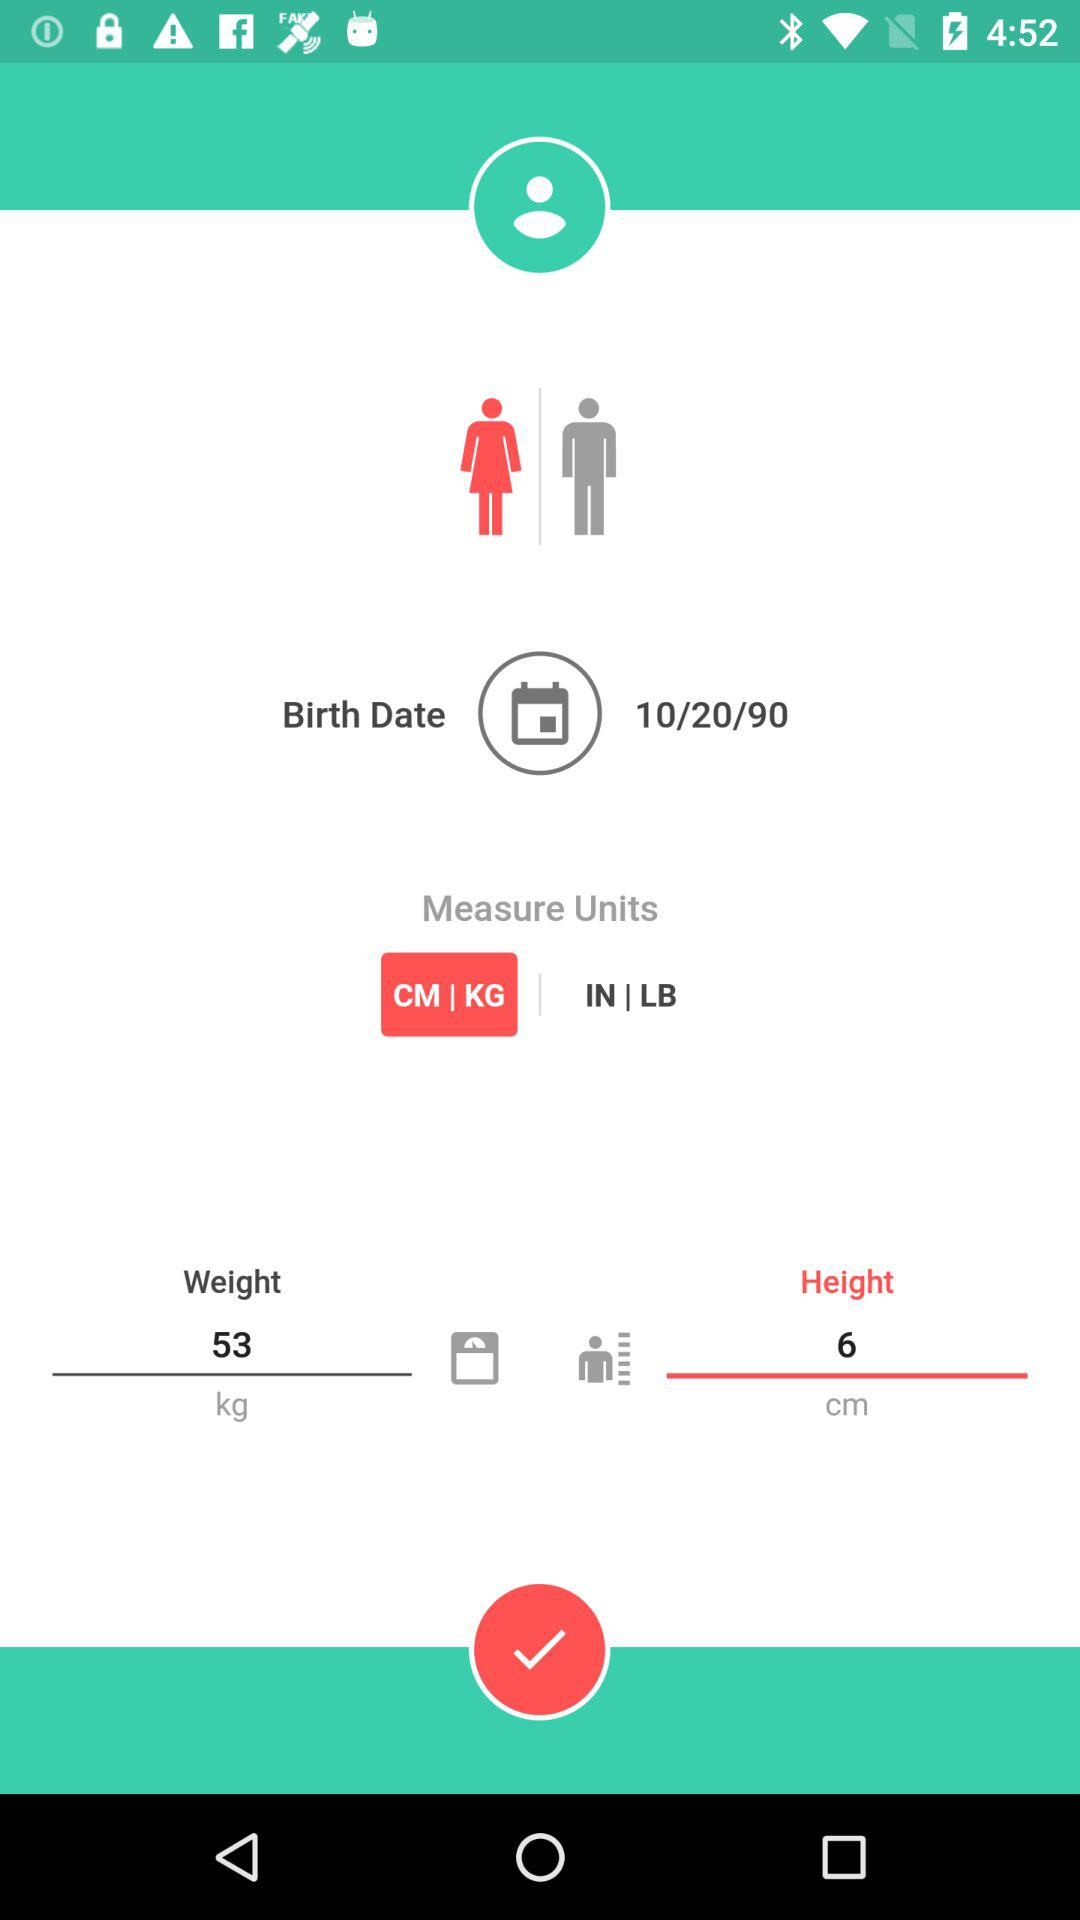What is the selected gender? The selected gender is "female". 